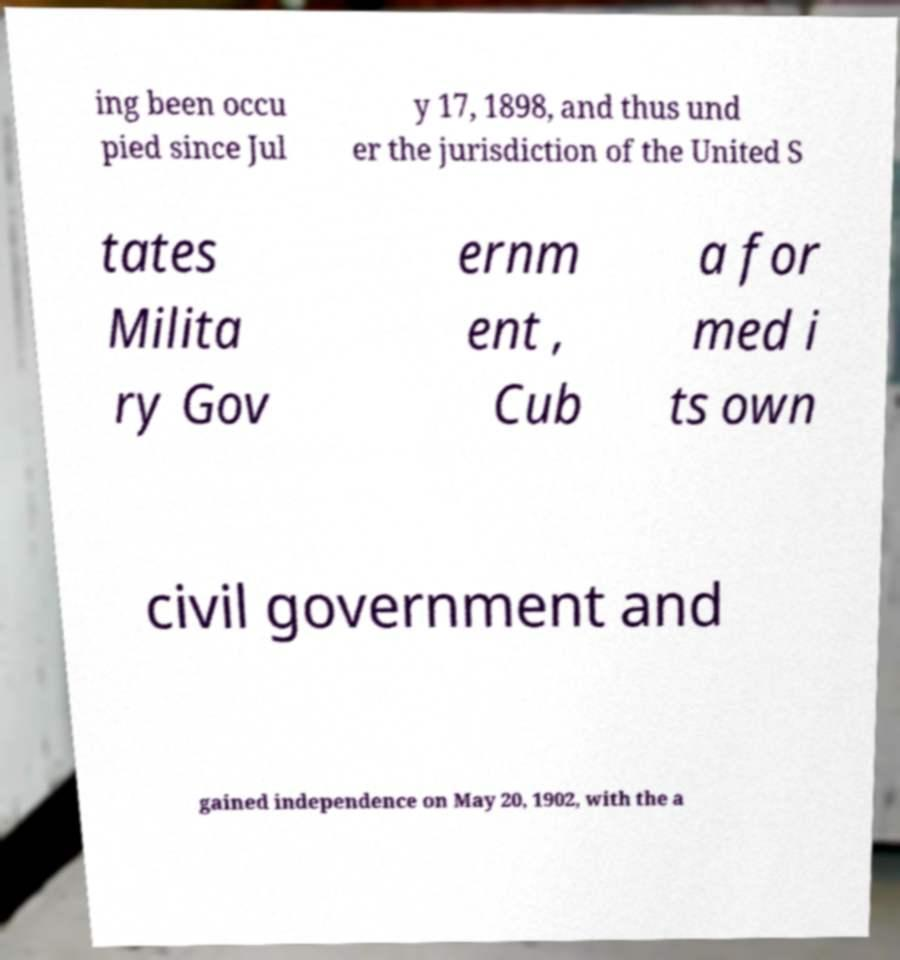Could you assist in decoding the text presented in this image and type it out clearly? ing been occu pied since Jul y 17, 1898, and thus und er the jurisdiction of the United S tates Milita ry Gov ernm ent , Cub a for med i ts own civil government and gained independence on May 20, 1902, with the a 